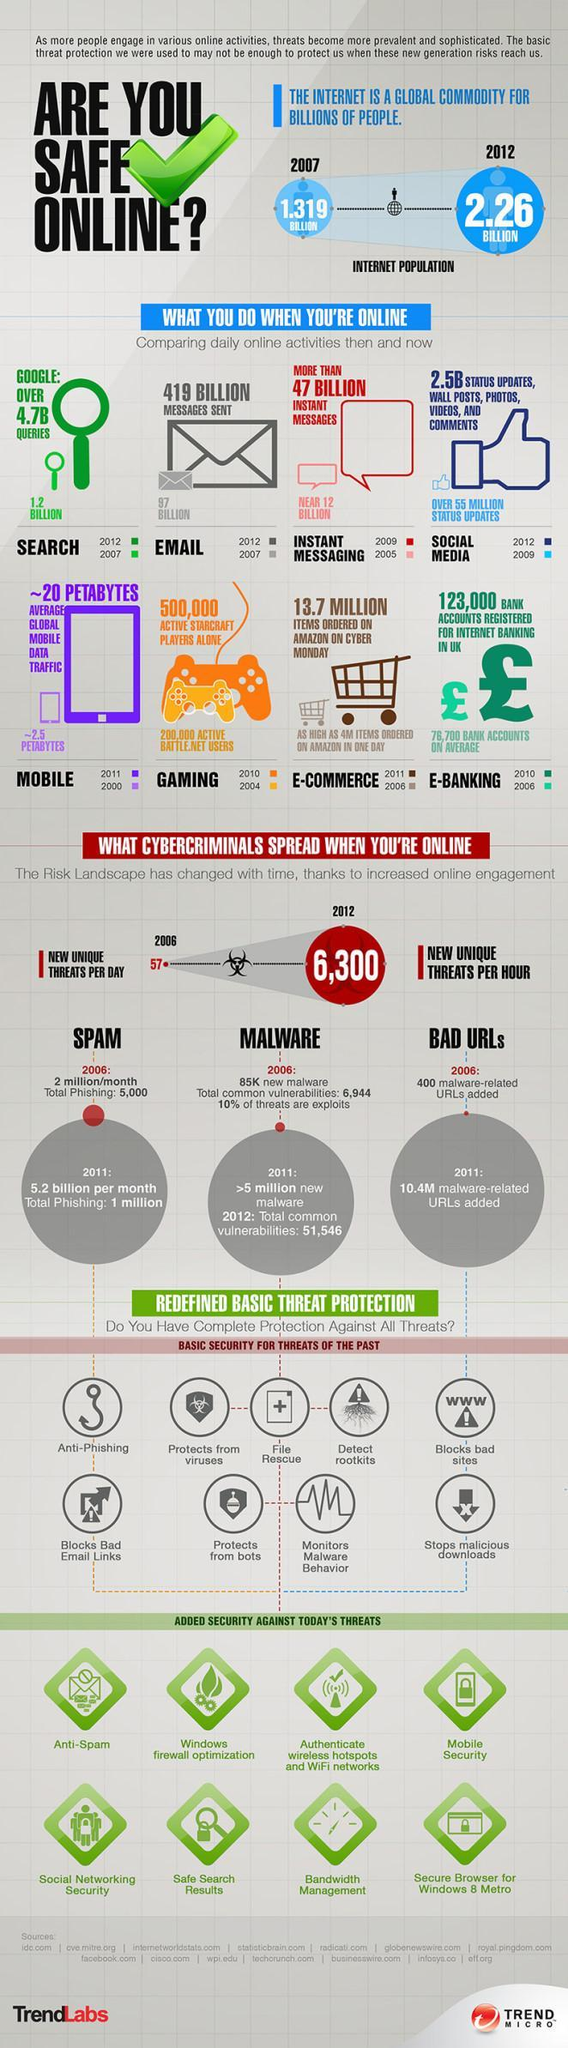By what number has the internet population increased form 2007 to 2012?
Answer the question with a short phrase. 0.941 BILLION 